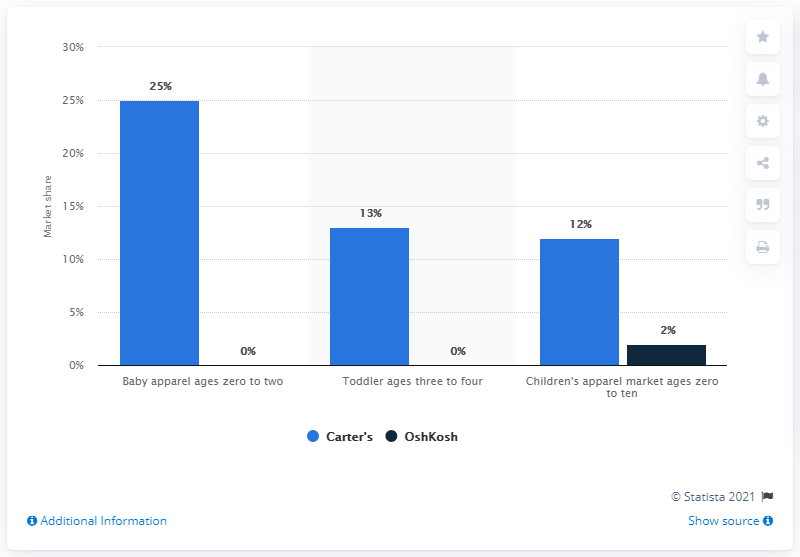What does the graph tell us about OshKosh's presence in the market segments displayed? According to the graph, OshKosh does not have a presence in the baby apparel market for ages zero to two, nor in the toddler market for ages three to four, as their market share is represented as 0% in both categories. However, OshKosh does hold a 2% share in the children's apparel market for ages zero to ten. This suggests that OshKosh has a much smaller foothold in these segments compared to Carter's. 